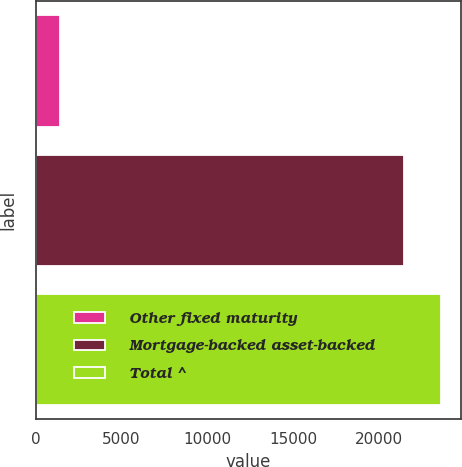Convert chart to OTSL. <chart><loc_0><loc_0><loc_500><loc_500><bar_chart><fcel>Other fixed maturity<fcel>Mortgage-backed asset-backed<fcel>Total ^<nl><fcel>1405<fcel>21485<fcel>23633.5<nl></chart> 